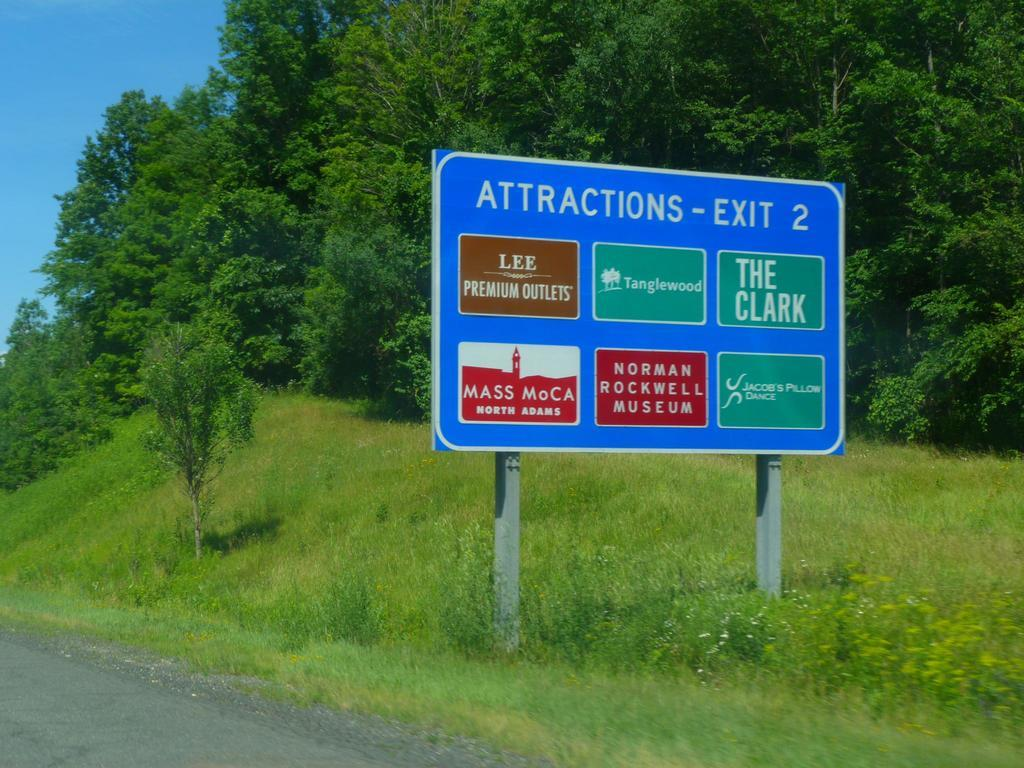<image>
Give a short and clear explanation of the subsequent image. exit sign is taking you to the attractions 